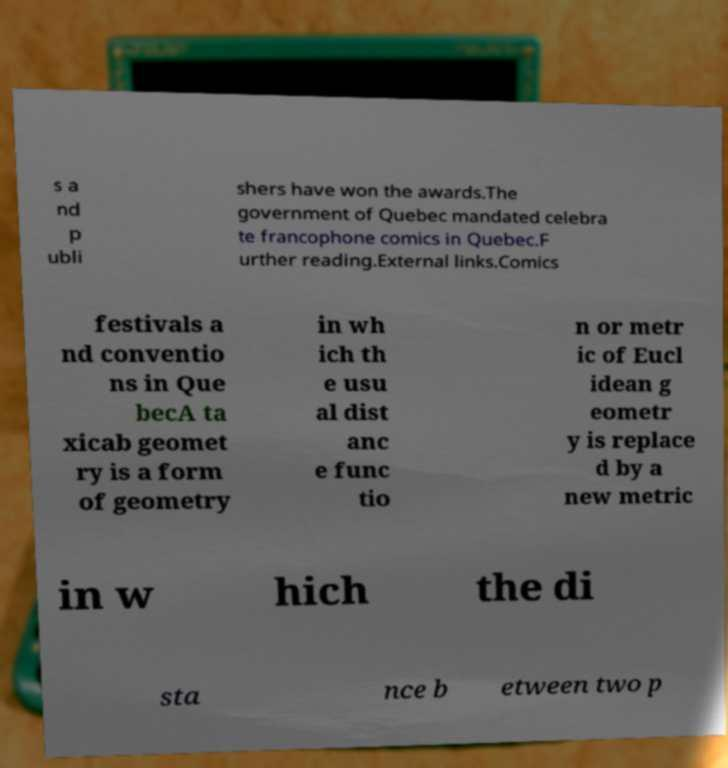There's text embedded in this image that I need extracted. Can you transcribe it verbatim? s a nd p ubli shers have won the awards.The government of Quebec mandated celebra te francophone comics in Quebec.F urther reading.External links.Comics festivals a nd conventio ns in Que becA ta xicab geomet ry is a form of geometry in wh ich th e usu al dist anc e func tio n or metr ic of Eucl idean g eometr y is replace d by a new metric in w hich the di sta nce b etween two p 